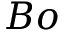<formula> <loc_0><loc_0><loc_500><loc_500>B o</formula> 